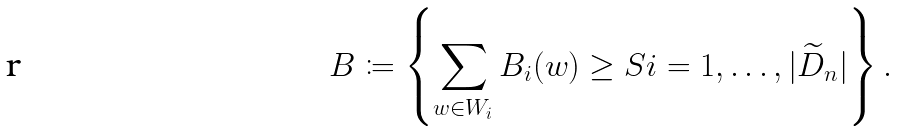<formula> <loc_0><loc_0><loc_500><loc_500>B \coloneqq \left \{ \sum _ { w \in W _ { i } } B _ { i } ( w ) \geq S i = 1 , \dots , | \widetilde { D } _ { n } | \right \} .</formula> 